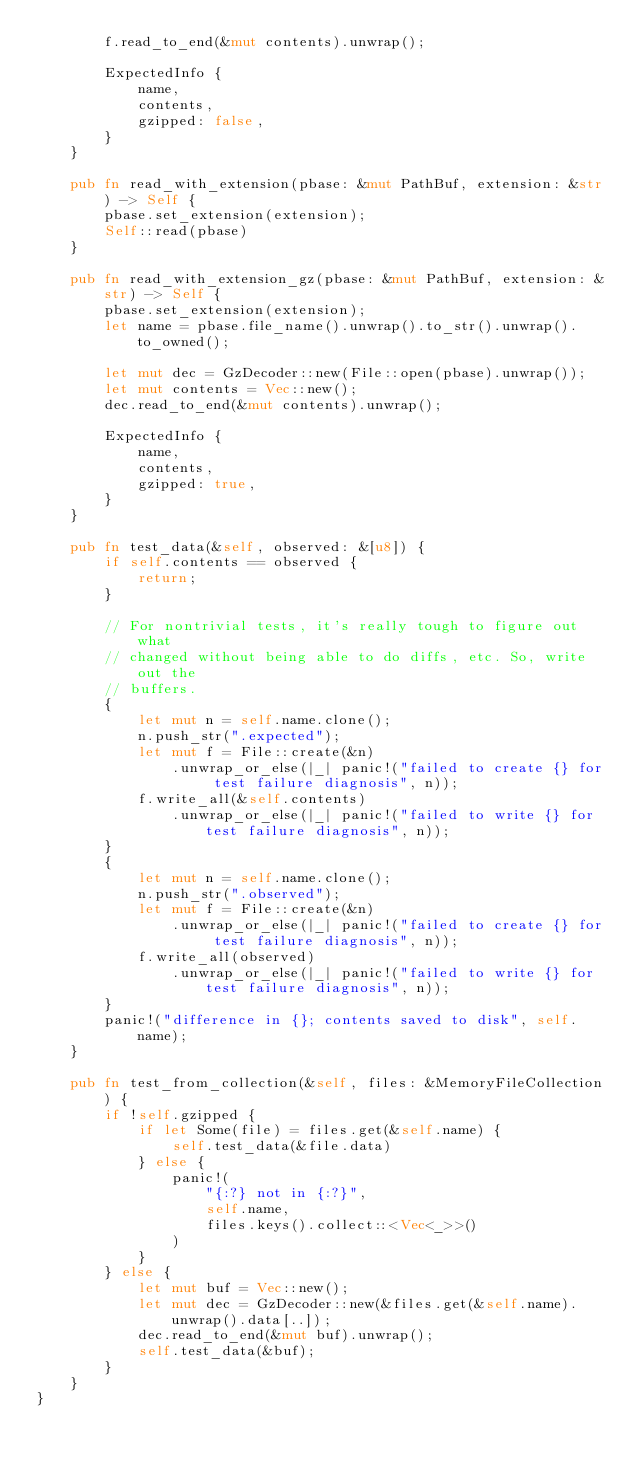Convert code to text. <code><loc_0><loc_0><loc_500><loc_500><_Rust_>        f.read_to_end(&mut contents).unwrap();

        ExpectedInfo {
            name,
            contents,
            gzipped: false,
        }
    }

    pub fn read_with_extension(pbase: &mut PathBuf, extension: &str) -> Self {
        pbase.set_extension(extension);
        Self::read(pbase)
    }

    pub fn read_with_extension_gz(pbase: &mut PathBuf, extension: &str) -> Self {
        pbase.set_extension(extension);
        let name = pbase.file_name().unwrap().to_str().unwrap().to_owned();

        let mut dec = GzDecoder::new(File::open(pbase).unwrap());
        let mut contents = Vec::new();
        dec.read_to_end(&mut contents).unwrap();

        ExpectedInfo {
            name,
            contents,
            gzipped: true,
        }
    }

    pub fn test_data(&self, observed: &[u8]) {
        if self.contents == observed {
            return;
        }

        // For nontrivial tests, it's really tough to figure out what
        // changed without being able to do diffs, etc. So, write out the
        // buffers.
        {
            let mut n = self.name.clone();
            n.push_str(".expected");
            let mut f = File::create(&n)
                .unwrap_or_else(|_| panic!("failed to create {} for test failure diagnosis", n));
            f.write_all(&self.contents)
                .unwrap_or_else(|_| panic!("failed to write {} for test failure diagnosis", n));
        }
        {
            let mut n = self.name.clone();
            n.push_str(".observed");
            let mut f = File::create(&n)
                .unwrap_or_else(|_| panic!("failed to create {} for test failure diagnosis", n));
            f.write_all(observed)
                .unwrap_or_else(|_| panic!("failed to write {} for test failure diagnosis", n));
        }
        panic!("difference in {}; contents saved to disk", self.name);
    }

    pub fn test_from_collection(&self, files: &MemoryFileCollection) {
        if !self.gzipped {
            if let Some(file) = files.get(&self.name) {
                self.test_data(&file.data)
            } else {
                panic!(
                    "{:?} not in {:?}",
                    self.name,
                    files.keys().collect::<Vec<_>>()
                )
            }
        } else {
            let mut buf = Vec::new();
            let mut dec = GzDecoder::new(&files.get(&self.name).unwrap().data[..]);
            dec.read_to_end(&mut buf).unwrap();
            self.test_data(&buf);
        }
    }
}
</code> 